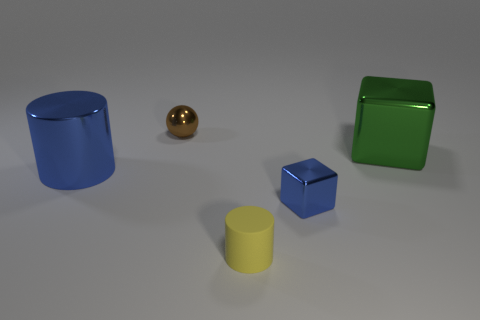Add 4 matte cylinders. How many objects exist? 9 Subtract all spheres. How many objects are left? 4 Add 2 green cubes. How many green cubes are left? 3 Add 1 big blue metallic objects. How many big blue metallic objects exist? 2 Subtract 0 cyan spheres. How many objects are left? 5 Subtract all big blue matte cylinders. Subtract all blue blocks. How many objects are left? 4 